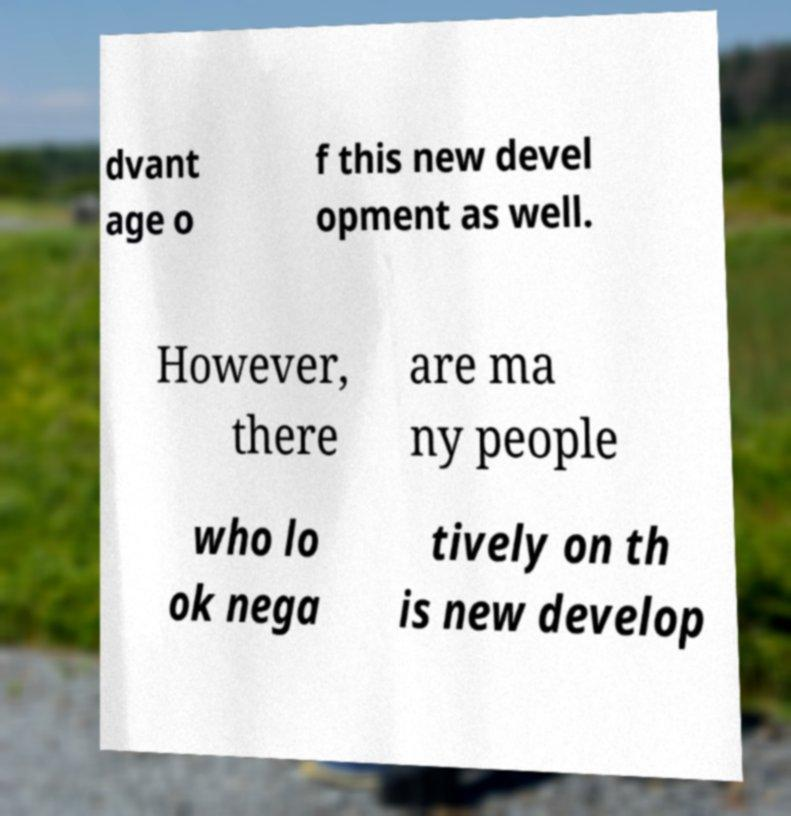Can you accurately transcribe the text from the provided image for me? dvant age o f this new devel opment as well. However, there are ma ny people who lo ok nega tively on th is new develop 